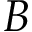<formula> <loc_0><loc_0><loc_500><loc_500>B</formula> 